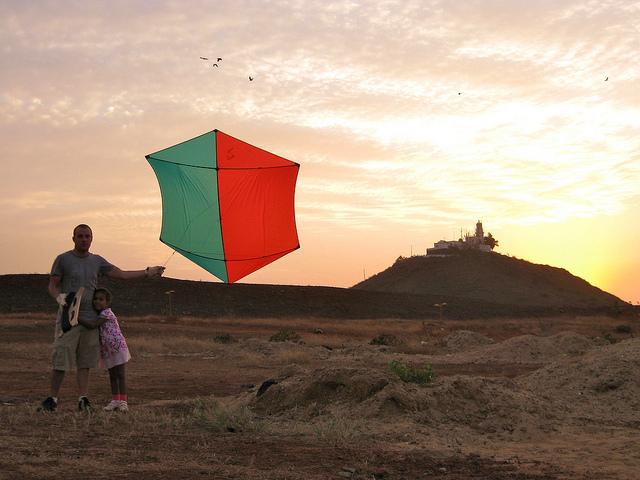What color are the skies?
Give a very brief answer. Orange. What is the relative temperature?
Concise answer only. Warm. Do these people know each other?
Write a very short answer. Yes. How can you tell that the little person is probably a girl?
Concise answer only. Dress. Is it raining?
Keep it brief. No. Does the girl like the man?
Be succinct. Yes. 